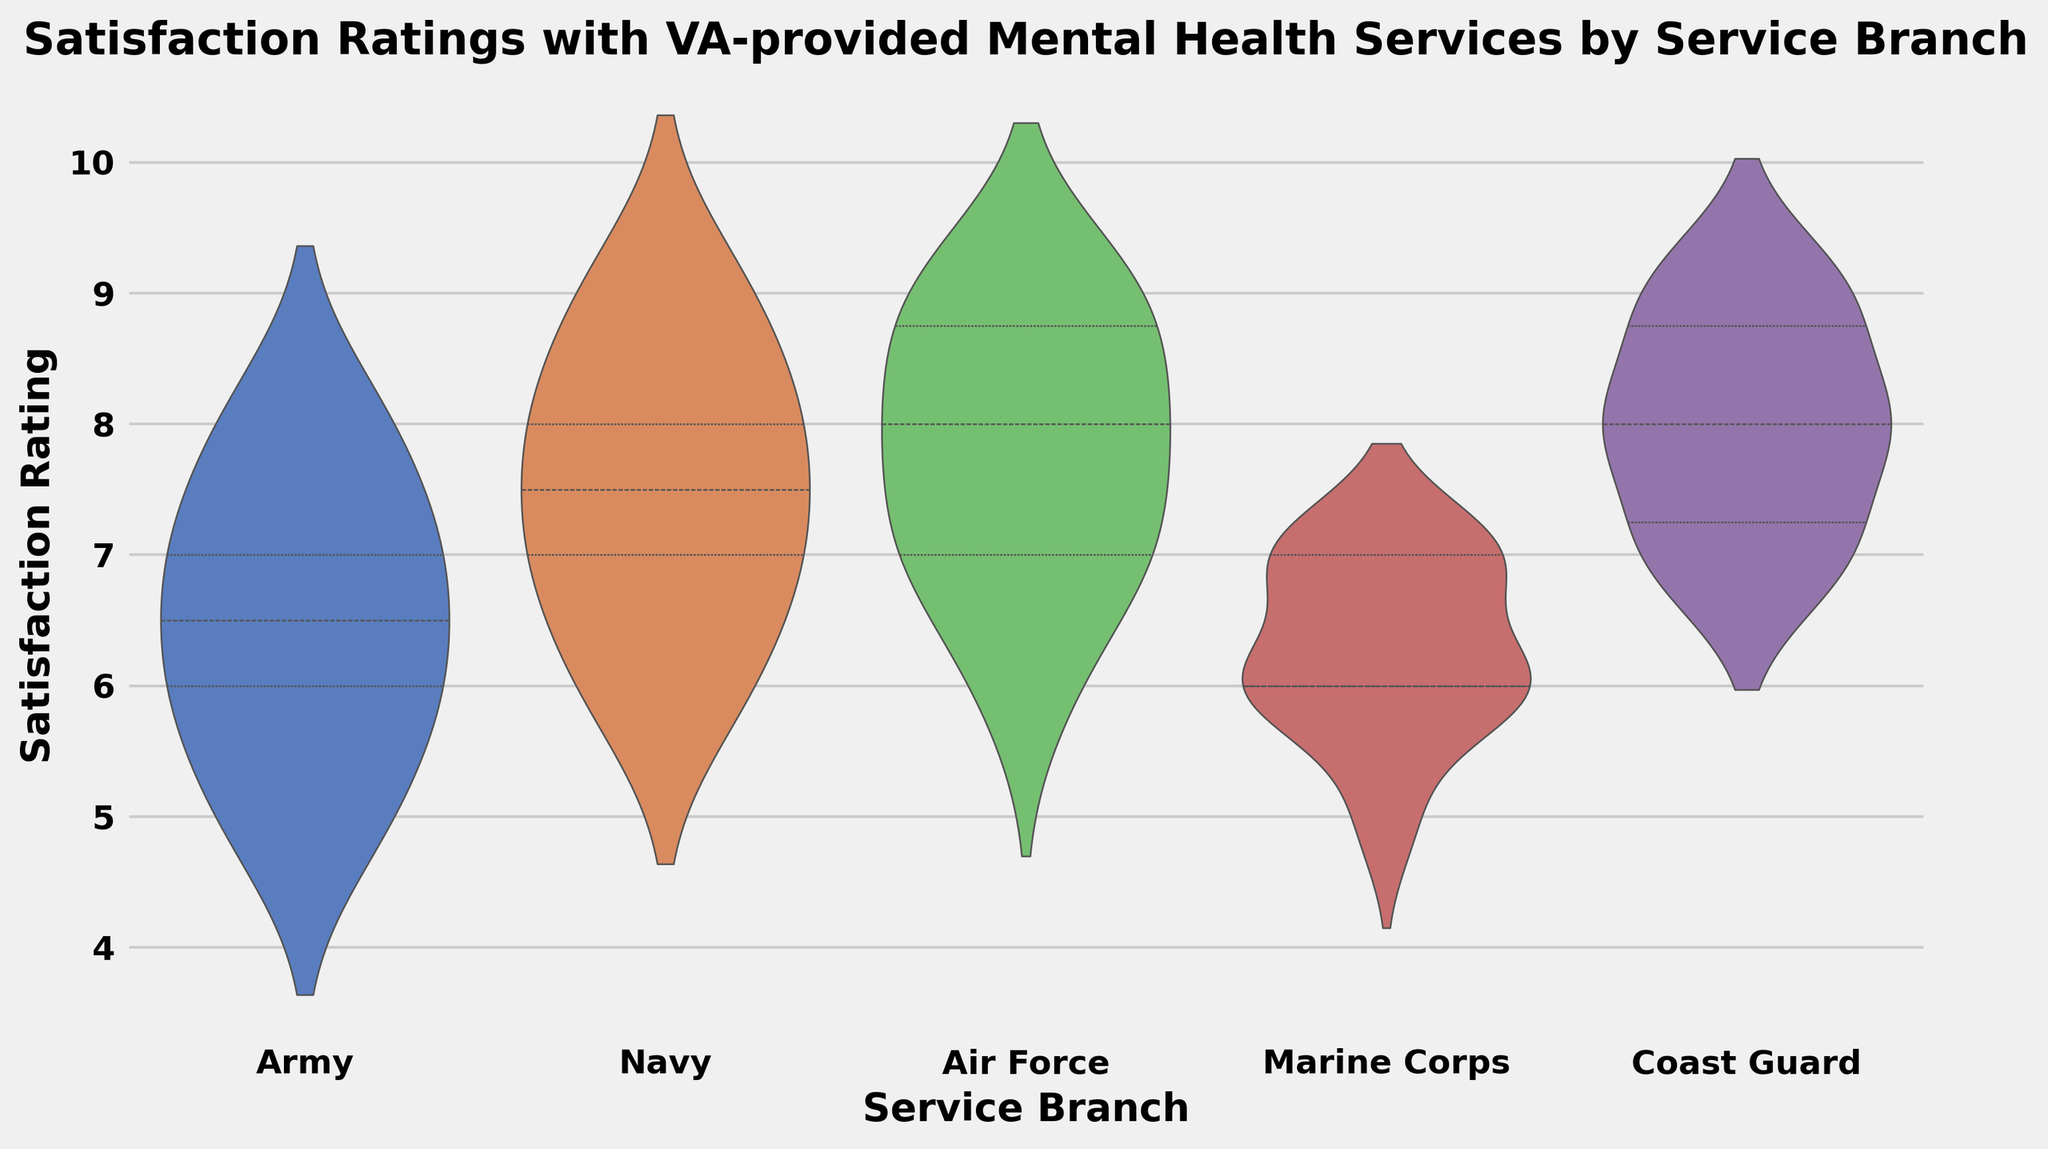What's the overall trend in satisfaction ratings across the different service branches? The violin plot shows areas where ratings are concentrated for each branch. The Army and Marine Corps have a range of satisfaction ratings that are generally lower relative to other branches, with more density around the median. The Navy, Air Force, and Coast Guard have higher and more concentrated ratings, indicating better overall satisfaction.
Answer: Ratings are higher for the Navy, Air Force, and Coast Guard, and lower for the Army and Marine Corps Which service branch has the highest median satisfaction rating? The median is represented by the white dot within each violin. By looking closely, Coast Guard's median rating is the highest among all service branches.
Answer: Coast Guard Comparing the Army and Navy, which has a wider range of satisfaction ratings? The width of the violin plot's span can indicate the range of the data. The Army's violin is wider and has fatter tails, indicating a wider spread compared to the Navy.
Answer: Army What is the interquartile range for the Air Force's satisfaction ratings? The interquartile range (IQR) is shown by the thick bar within the violin plot. For the Air Force, the IQR spans from the first quartile (towards the lower bound of the bar) to the third quartile (upper bound of the bar). Estimating visually, the IQR for the Air Force stretches between 7 and 9.
Answer: Approximately 2 (from 7 to 9) Which branches have only a single peak in their satisfaction ratings? Single peaks indicate higher density in specific ratings. Both the Air Force and Coast Guard have a single peak or mode around their median values, suggesting consistent satisfaction ratings around that point.
Answer: Air Force, Coast Guard 